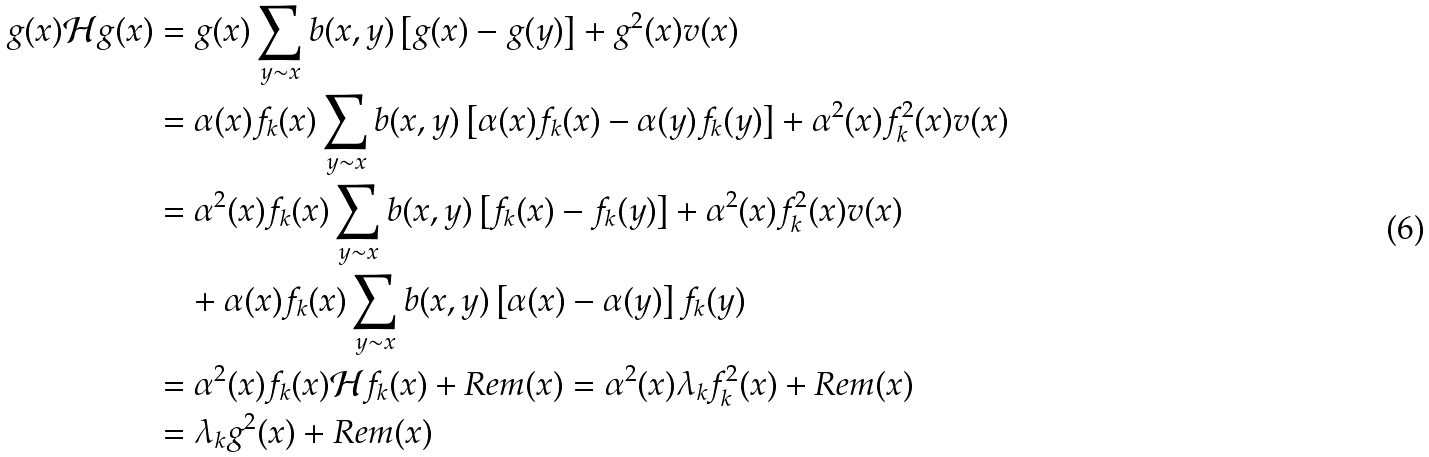<formula> <loc_0><loc_0><loc_500><loc_500>g ( x ) \mathcal { H } g ( x ) & = g ( x ) \sum _ { y \sim x } b ( x , y ) \left [ g ( x ) - g ( y ) \right ] + g ^ { 2 } ( x ) v ( x ) \\ & = \alpha ( x ) f _ { k } ( x ) \sum _ { y \sim x } b ( x , y ) \left [ \alpha ( x ) f _ { k } ( x ) - \alpha ( y ) f _ { k } ( y ) \right ] + \alpha ^ { 2 } ( x ) f _ { k } ^ { 2 } ( x ) v ( x ) \\ & = \alpha ^ { 2 } ( x ) f _ { k } ( x ) \sum _ { y \sim x } b ( x , y ) \left [ f _ { k } ( x ) - f _ { k } ( y ) \right ] + \alpha ^ { 2 } ( x ) f _ { k } ^ { 2 } ( x ) v ( x ) \\ & \quad + \alpha ( x ) f _ { k } ( x ) \sum _ { y \sim x } b ( x , y ) \left [ \alpha ( x ) - \alpha ( y ) \right ] f _ { k } ( y ) \\ & = \alpha ^ { 2 } ( x ) f _ { k } ( x ) \mathcal { H } f _ { k } ( x ) + R e m ( x ) = \alpha ^ { 2 } ( x ) \lambda _ { k } f _ { k } ^ { 2 } ( x ) + R e m ( x ) \\ & = \lambda _ { k } g ^ { 2 } ( x ) + R e m ( x )</formula> 